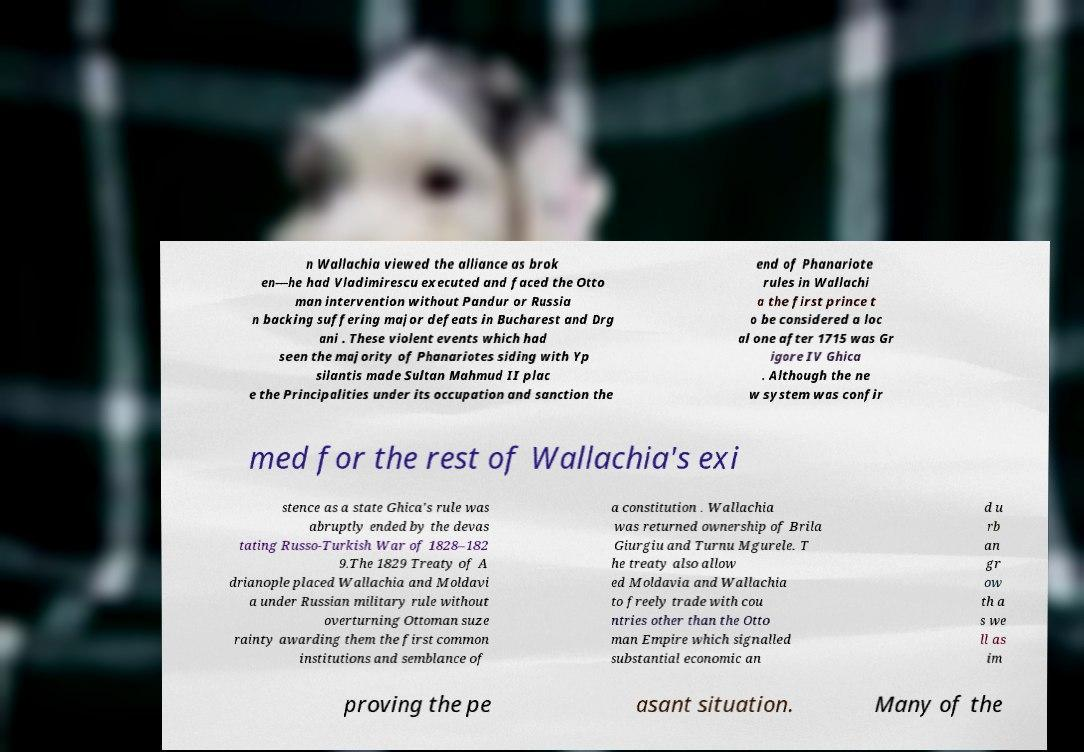I need the written content from this picture converted into text. Can you do that? n Wallachia viewed the alliance as brok en—he had Vladimirescu executed and faced the Otto man intervention without Pandur or Russia n backing suffering major defeats in Bucharest and Drg ani . These violent events which had seen the majority of Phanariotes siding with Yp silantis made Sultan Mahmud II plac e the Principalities under its occupation and sanction the end of Phanariote rules in Wallachi a the first prince t o be considered a loc al one after 1715 was Gr igore IV Ghica . Although the ne w system was confir med for the rest of Wallachia's exi stence as a state Ghica's rule was abruptly ended by the devas tating Russo-Turkish War of 1828–182 9.The 1829 Treaty of A drianople placed Wallachia and Moldavi a under Russian military rule without overturning Ottoman suze rainty awarding them the first common institutions and semblance of a constitution . Wallachia was returned ownership of Brila Giurgiu and Turnu Mgurele. T he treaty also allow ed Moldavia and Wallachia to freely trade with cou ntries other than the Otto man Empire which signalled substantial economic an d u rb an gr ow th a s we ll as im proving the pe asant situation. Many of the 